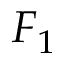Convert formula to latex. <formula><loc_0><loc_0><loc_500><loc_500>F _ { 1 }</formula> 